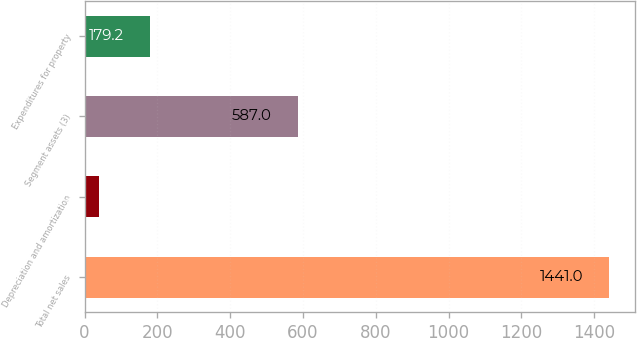<chart> <loc_0><loc_0><loc_500><loc_500><bar_chart><fcel>Total net sales<fcel>Depreciation and amortization<fcel>Segment assets (3)<fcel>Expenditures for property<nl><fcel>1441<fcel>39<fcel>587<fcel>179.2<nl></chart> 